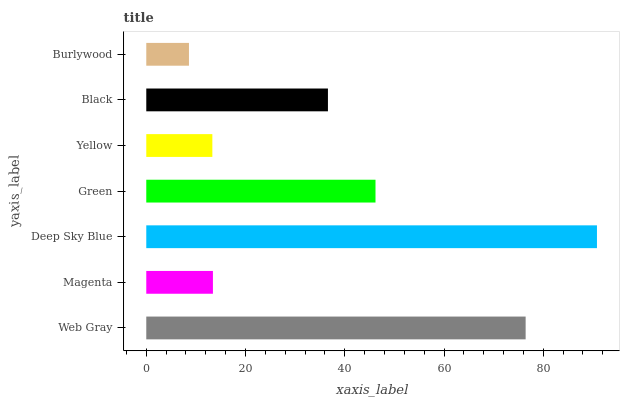Is Burlywood the minimum?
Answer yes or no. Yes. Is Deep Sky Blue the maximum?
Answer yes or no. Yes. Is Magenta the minimum?
Answer yes or no. No. Is Magenta the maximum?
Answer yes or no. No. Is Web Gray greater than Magenta?
Answer yes or no. Yes. Is Magenta less than Web Gray?
Answer yes or no. Yes. Is Magenta greater than Web Gray?
Answer yes or no. No. Is Web Gray less than Magenta?
Answer yes or no. No. Is Black the high median?
Answer yes or no. Yes. Is Black the low median?
Answer yes or no. Yes. Is Deep Sky Blue the high median?
Answer yes or no. No. Is Magenta the low median?
Answer yes or no. No. 